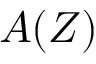<formula> <loc_0><loc_0><loc_500><loc_500>A ( Z )</formula> 